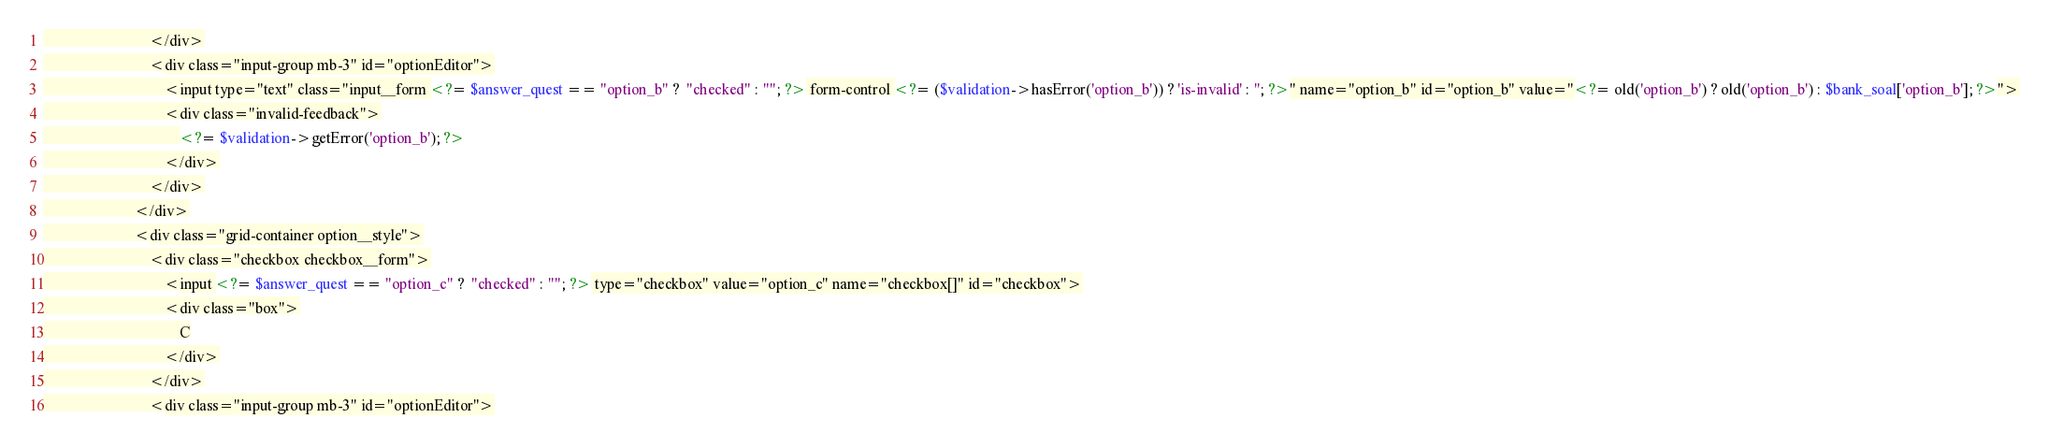<code> <loc_0><loc_0><loc_500><loc_500><_PHP_>                            </div>
                            <div class="input-group mb-3" id="optionEditor">
                                <input type="text" class="input__form <?= $answer_quest == "option_b" ?  "checked" : ""; ?> form-control <?= ($validation->hasError('option_b')) ? 'is-invalid' : ''; ?>" name="option_b" id="option_b" value="<?= old('option_b') ? old('option_b') : $bank_soal['option_b']; ?>">
                                <div class="invalid-feedback">
                                    <?= $validation->getError('option_b'); ?>
                                </div>
                            </div>
                        </div>
                        <div class="grid-container option__style">
                            <div class="checkbox checkbox__form">
                                <input <?= $answer_quest == "option_c" ?  "checked" : ""; ?> type="checkbox" value="option_c" name="checkbox[]" id="checkbox">
                                <div class="box">
                                    C
                                </div>
                            </div>
                            <div class="input-group mb-3" id="optionEditor"></code> 